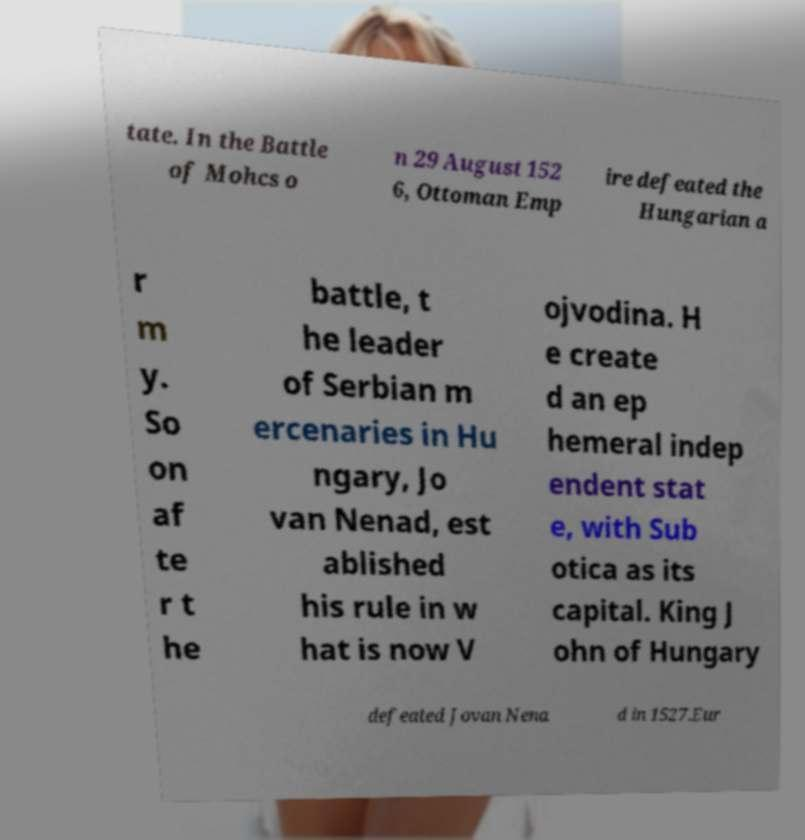Please read and relay the text visible in this image. What does it say? tate. In the Battle of Mohcs o n 29 August 152 6, Ottoman Emp ire defeated the Hungarian a r m y. So on af te r t he battle, t he leader of Serbian m ercenaries in Hu ngary, Jo van Nenad, est ablished his rule in w hat is now V ojvodina. H e create d an ep hemeral indep endent stat e, with Sub otica as its capital. King J ohn of Hungary defeated Jovan Nena d in 1527.Eur 